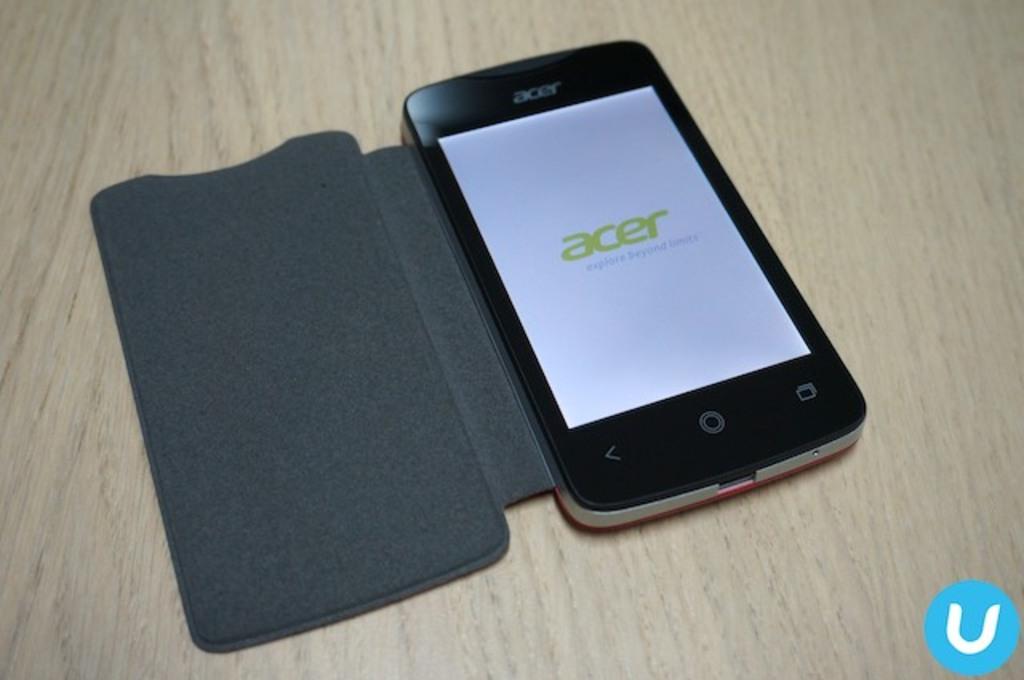What company made this phone?
Give a very brief answer. Acer. 